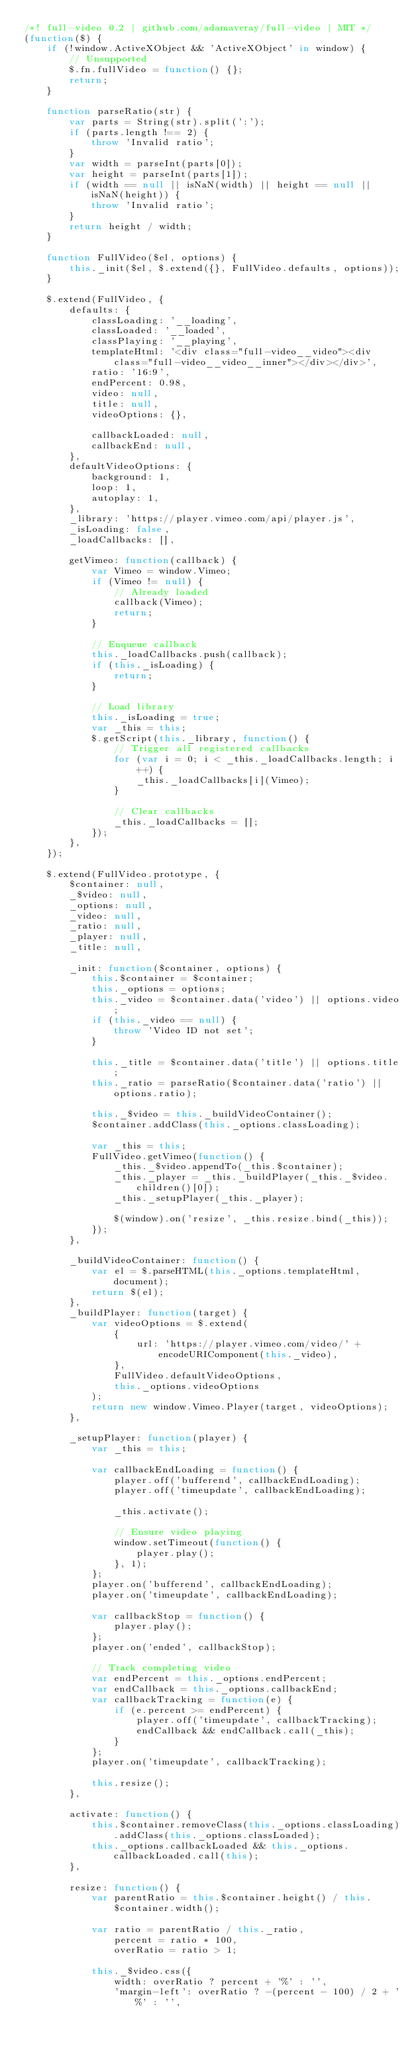<code> <loc_0><loc_0><loc_500><loc_500><_JavaScript_>/*! full-video 0.2 | github.com/adamaveray/full-video | MIT */
(function($) {
    if (!window.ActiveXObject && 'ActiveXObject' in window) {
        // Unsupported
        $.fn.fullVideo = function() {};
        return;
    }

    function parseRatio(str) {
        var parts = String(str).split(':');
        if (parts.length !== 2) {
            throw 'Invalid ratio';
        }
        var width = parseInt(parts[0]);
        var height = parseInt(parts[1]);
        if (width == null || isNaN(width) || height == null || isNaN(height)) {
            throw 'Invalid ratio';
        }
        return height / width;
    }

    function FullVideo($el, options) {
        this._init($el, $.extend({}, FullVideo.defaults, options));
    }

    $.extend(FullVideo, {
        defaults: {
            classLoading: '__loading',
            classLoaded: '__loaded',
            classPlaying: '__playing',
            templateHtml: '<div class="full-video__video"><div class="full-video__video__inner"></div></div>',
            ratio: '16:9',
            endPercent: 0.98,
            video: null,
            title: null,
            videoOptions: {},

            callbackLoaded: null,
            callbackEnd: null,
        },
        defaultVideoOptions: {
            background: 1,
            loop: 1,
            autoplay: 1,
        },
        _library: 'https://player.vimeo.com/api/player.js',
        _isLoading: false,
        _loadCallbacks: [],

        getVimeo: function(callback) {
            var Vimeo = window.Vimeo;
            if (Vimeo != null) {
                // Already loaded
                callback(Vimeo);
                return;
            }

            // Enqueue callback
            this._loadCallbacks.push(callback);
            if (this._isLoading) {
                return;
            }

            // Load library
            this._isLoading = true;
            var _this = this;
            $.getScript(this._library, function() {
                // Trigger all registered callbacks
                for (var i = 0; i < _this._loadCallbacks.length; i++) {
                    _this._loadCallbacks[i](Vimeo);
                }

                // Clear callbacks
                _this._loadCallbacks = [];
            });
        },
    });

    $.extend(FullVideo.prototype, {
        $container: null,
        _$video: null,
        _options: null,
        _video: null,
        _ratio: null,
        _player: null,
        _title: null,

        _init: function($container, options) {
            this.$container = $container;
            this._options = options;
            this._video = $container.data('video') || options.video;
            if (this._video == null) {
                throw 'Video ID not set';
            }

            this._title = $container.data('title') || options.title;
            this._ratio = parseRatio($container.data('ratio') || options.ratio);

            this._$video = this._buildVideoContainer();
            $container.addClass(this._options.classLoading);

            var _this = this;
            FullVideo.getVimeo(function() {
                _this._$video.appendTo(_this.$container);
                _this._player = _this._buildPlayer(_this._$video.children()[0]);
                _this._setupPlayer(_this._player);

                $(window).on('resize', _this.resize.bind(_this));
            });
        },

        _buildVideoContainer: function() {
            var el = $.parseHTML(this._options.templateHtml, document);
            return $(el);
        },
        _buildPlayer: function(target) {
            var videoOptions = $.extend(
                {
                    url: 'https://player.vimeo.com/video/' + encodeURIComponent(this._video),
                },
                FullVideo.defaultVideoOptions,
                this._options.videoOptions
            );
            return new window.Vimeo.Player(target, videoOptions);
        },

        _setupPlayer: function(player) {
            var _this = this;

            var callbackEndLoading = function() {
                player.off('bufferend', callbackEndLoading);
                player.off('timeupdate', callbackEndLoading);

                _this.activate();

                // Ensure video playing
                window.setTimeout(function() {
                    player.play();
                }, 1);
            };
            player.on('bufferend', callbackEndLoading);
            player.on('timeupdate', callbackEndLoading);

            var callbackStop = function() {
                player.play();
            };
            player.on('ended', callbackStop);

            // Track completing video
            var endPercent = this._options.endPercent;
            var endCallback = this._options.callbackEnd;
            var callbackTracking = function(e) {
                if (e.percent >= endPercent) {
                    player.off('timeupdate', callbackTracking);
                    endCallback && endCallback.call(_this);
                }
            };
            player.on('timeupdate', callbackTracking);

            this.resize();
        },

        activate: function() {
            this.$container.removeClass(this._options.classLoading).addClass(this._options.classLoaded);
            this._options.callbackLoaded && this._options.callbackLoaded.call(this);
        },

        resize: function() {
            var parentRatio = this.$container.height() / this.$container.width();

            var ratio = parentRatio / this._ratio,
                percent = ratio * 100,
                overRatio = ratio > 1;

            this._$video.css({
                width: overRatio ? percent + '%' : '',
                'margin-left': overRatio ? -(percent - 100) / 2 + '%' : '',</code> 